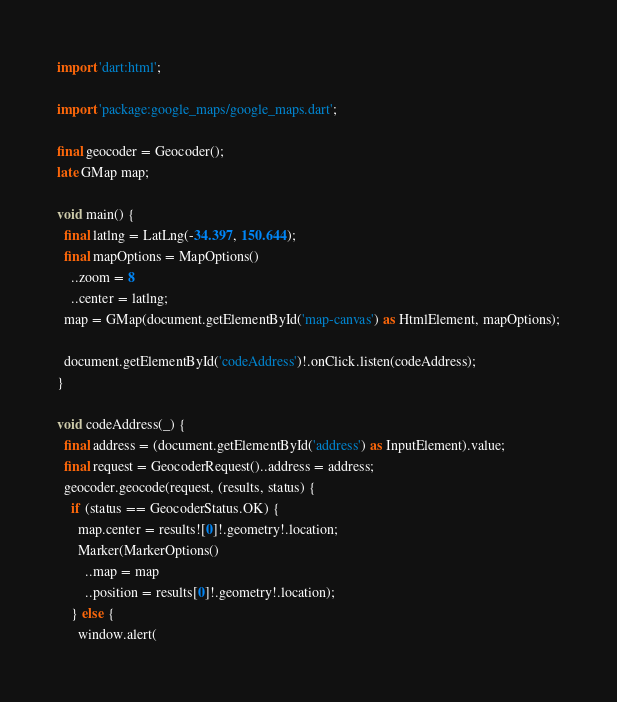Convert code to text. <code><loc_0><loc_0><loc_500><loc_500><_Dart_>import 'dart:html';

import 'package:google_maps/google_maps.dart';

final geocoder = Geocoder();
late GMap map;

void main() {
  final latlng = LatLng(-34.397, 150.644);
  final mapOptions = MapOptions()
    ..zoom = 8
    ..center = latlng;
  map = GMap(document.getElementById('map-canvas') as HtmlElement, mapOptions);

  document.getElementById('codeAddress')!.onClick.listen(codeAddress);
}

void codeAddress(_) {
  final address = (document.getElementById('address') as InputElement).value;
  final request = GeocoderRequest()..address = address;
  geocoder.geocode(request, (results, status) {
    if (status == GeocoderStatus.OK) {
      map.center = results![0]!.geometry!.location;
      Marker(MarkerOptions()
        ..map = map
        ..position = results[0]!.geometry!.location);
    } else {
      window.alert(</code> 